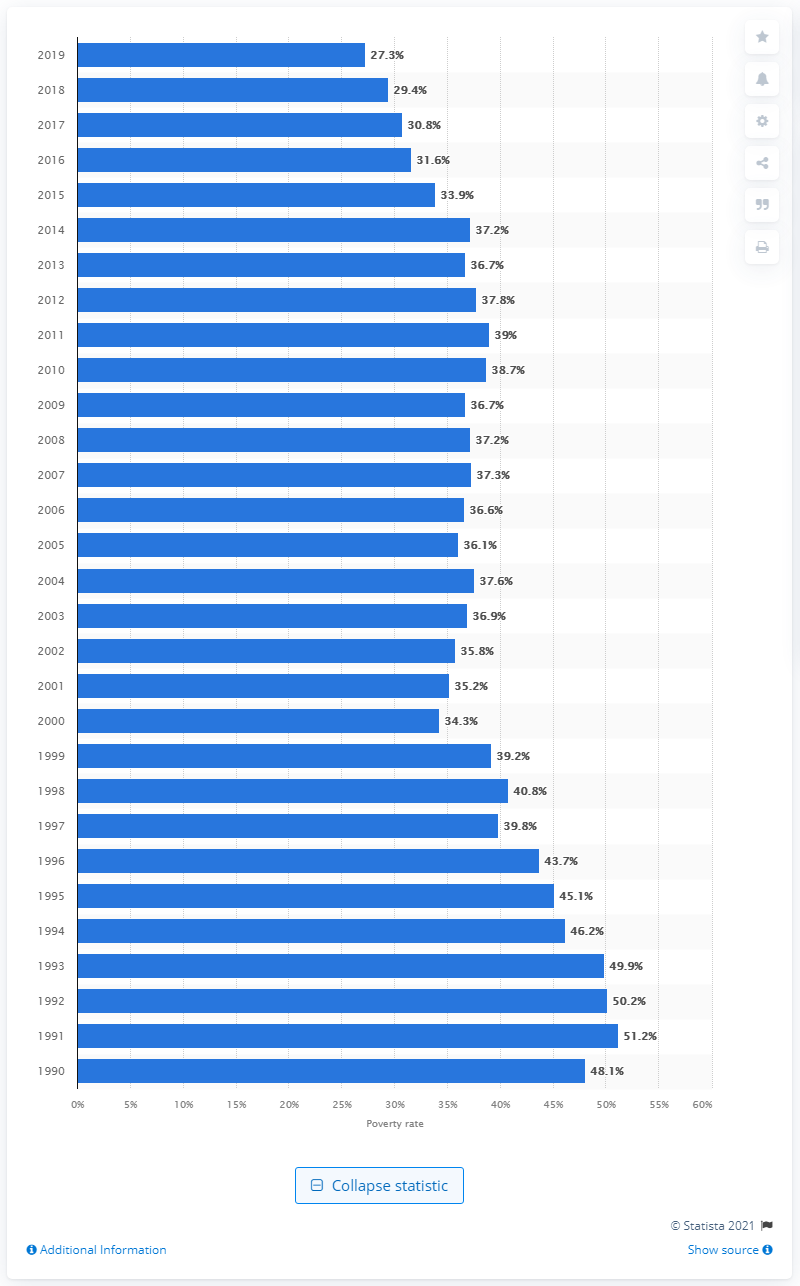Outline some significant characteristics in this image. In 1990, 48.1% of Black families with a single mother were living in poverty, according to data. In 2018, the poverty level was 27.3%. 